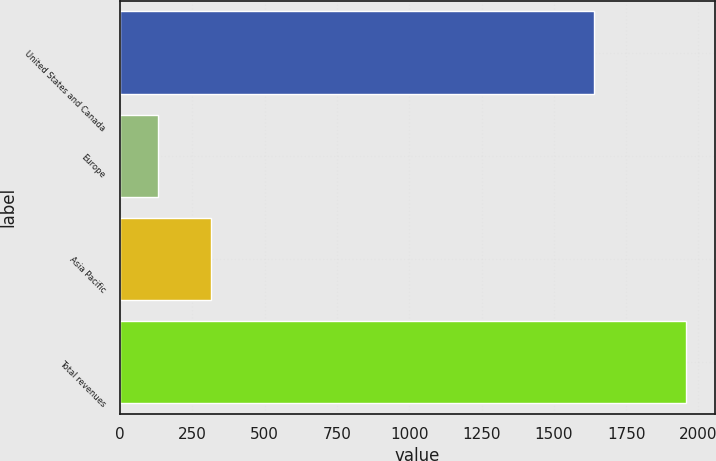<chart> <loc_0><loc_0><loc_500><loc_500><bar_chart><fcel>United States and Canada<fcel>Europe<fcel>Asia Pacific<fcel>Total revenues<nl><fcel>1639<fcel>130<fcel>312.8<fcel>1958<nl></chart> 